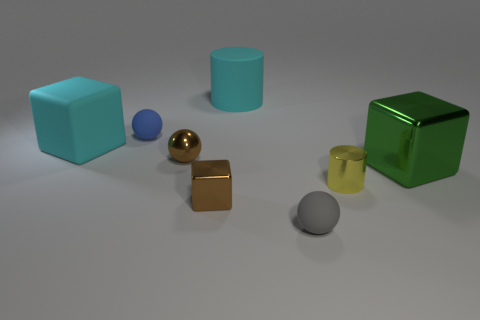The rubber object that is the same color as the big rubber cylinder is what size?
Provide a succinct answer. Large. Is the size of the ball that is behind the large cyan cube the same as the brown thing that is in front of the tiny yellow cylinder?
Offer a very short reply. Yes. There is a thing that is in front of the tiny yellow cylinder and to the right of the tiny metal cube; how big is it?
Keep it short and to the point. Small. There is another shiny thing that is the same shape as the small blue object; what is its color?
Your response must be concise. Brown. Is the number of cyan matte cubes that are on the left side of the big shiny thing greater than the number of small metal blocks in front of the gray matte sphere?
Provide a succinct answer. Yes. How many other objects are the same shape as the gray thing?
Ensure brevity in your answer.  2. Are there any tiny blue spheres that are to the left of the tiny blue sphere that is behind the large shiny cube?
Your answer should be compact. No. How many small yellow cylinders are there?
Offer a terse response. 1. There is a rubber cube; does it have the same color as the cylinder that is behind the large metal block?
Make the answer very short. Yes. Is the number of cylinders greater than the number of balls?
Offer a very short reply. No. 